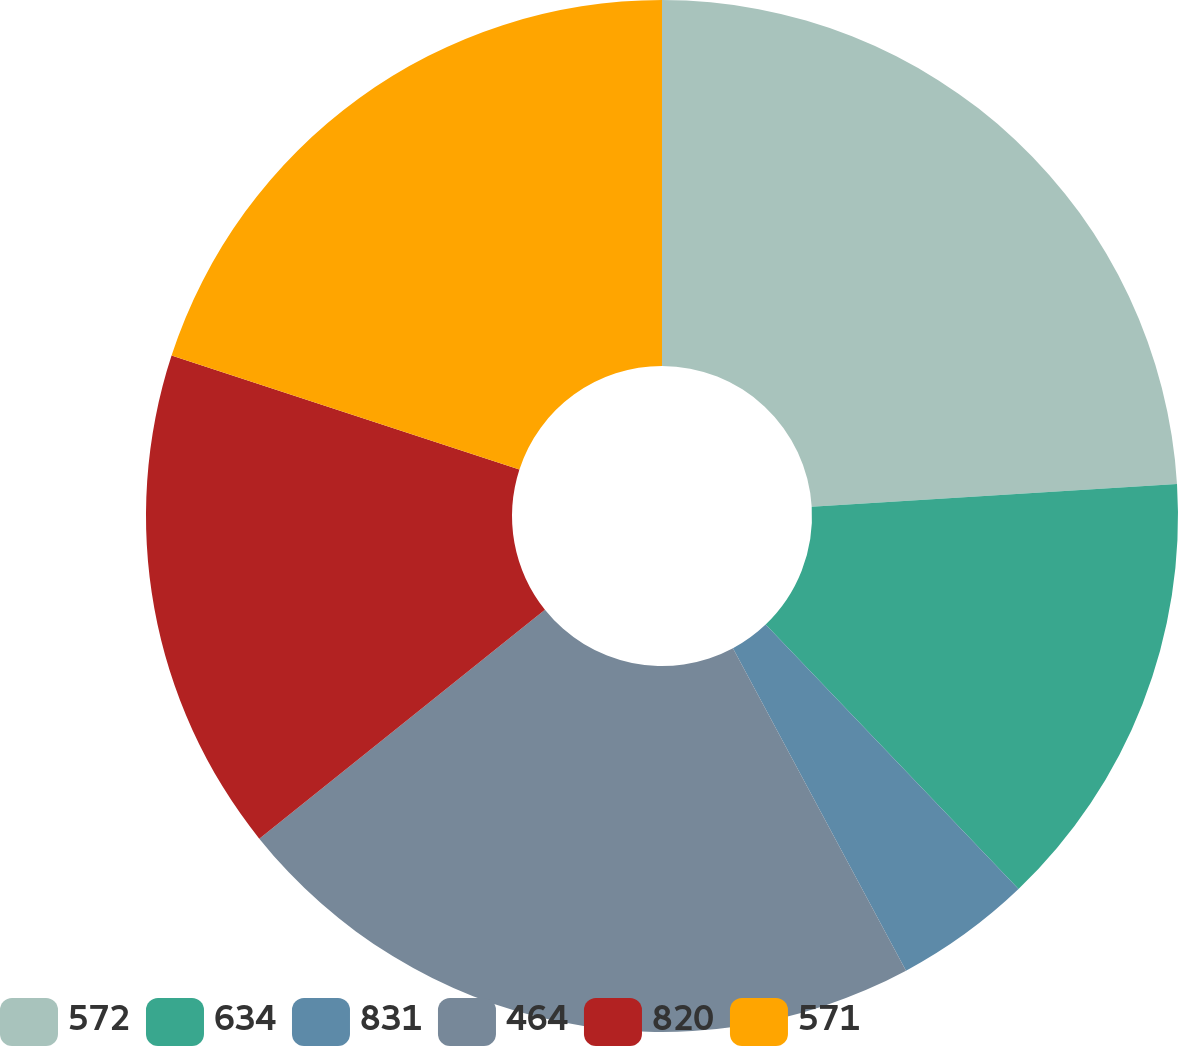Convert chart. <chart><loc_0><loc_0><loc_500><loc_500><pie_chart><fcel>572<fcel>634<fcel>831<fcel>464<fcel>820<fcel>571<nl><fcel>24.01%<fcel>13.85%<fcel>4.3%<fcel>22.09%<fcel>15.78%<fcel>19.97%<nl></chart> 